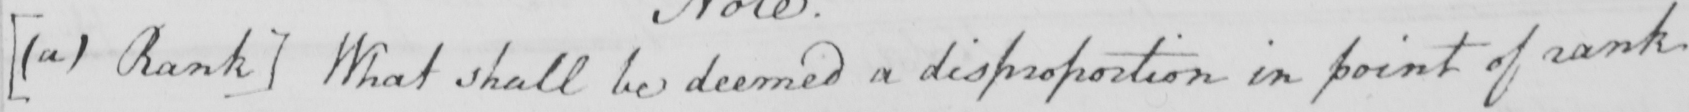What does this handwritten line say? [  ( a )  Rank ]  What shall be deemed a disproportion in point of rank 